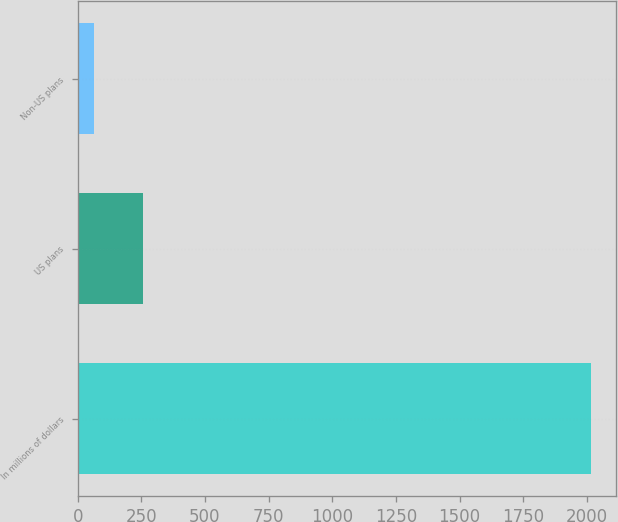Convert chart. <chart><loc_0><loc_0><loc_500><loc_500><bar_chart><fcel>In millions of dollars<fcel>US plans<fcel>Non-US plans<nl><fcel>2015<fcel>258.2<fcel>63<nl></chart> 